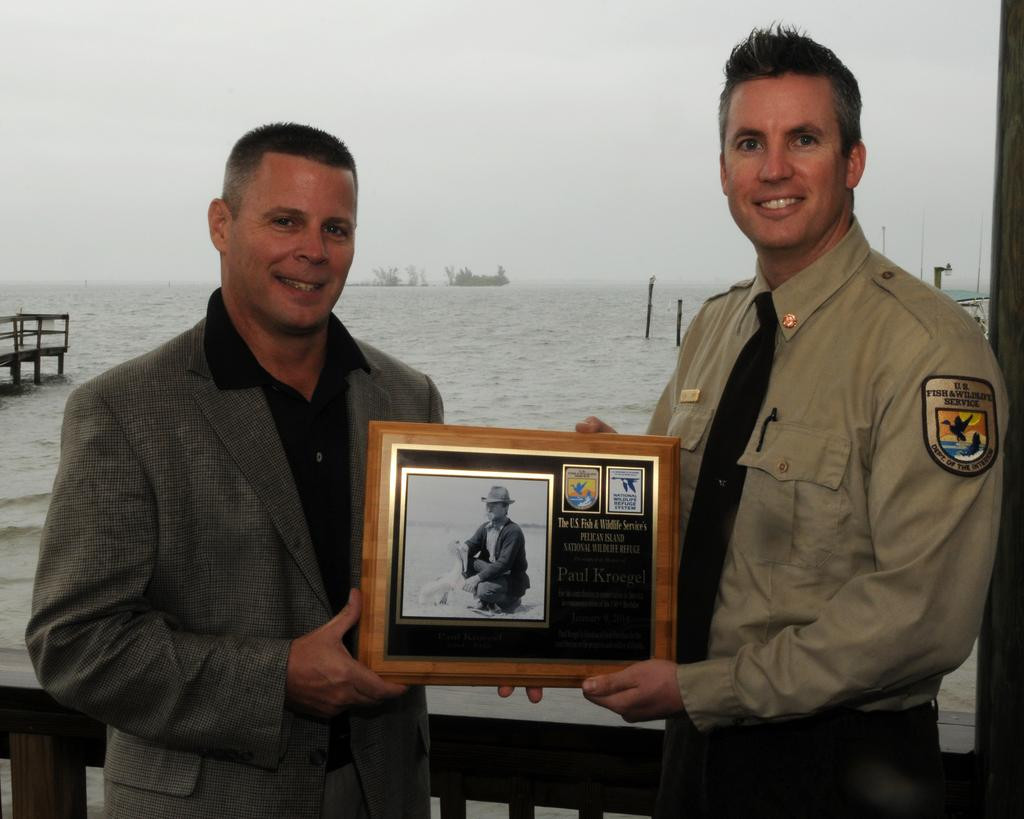How many people are in the image? There are two people standing in the center of the image. What are the two people holding? The two people are holding a photo frame. What can be seen in the background of the image? There is a fence, water, and the sky visible in the background of the image. What type of flesh can be seen on the roof in the image? There is no flesh or roof present in the image. 